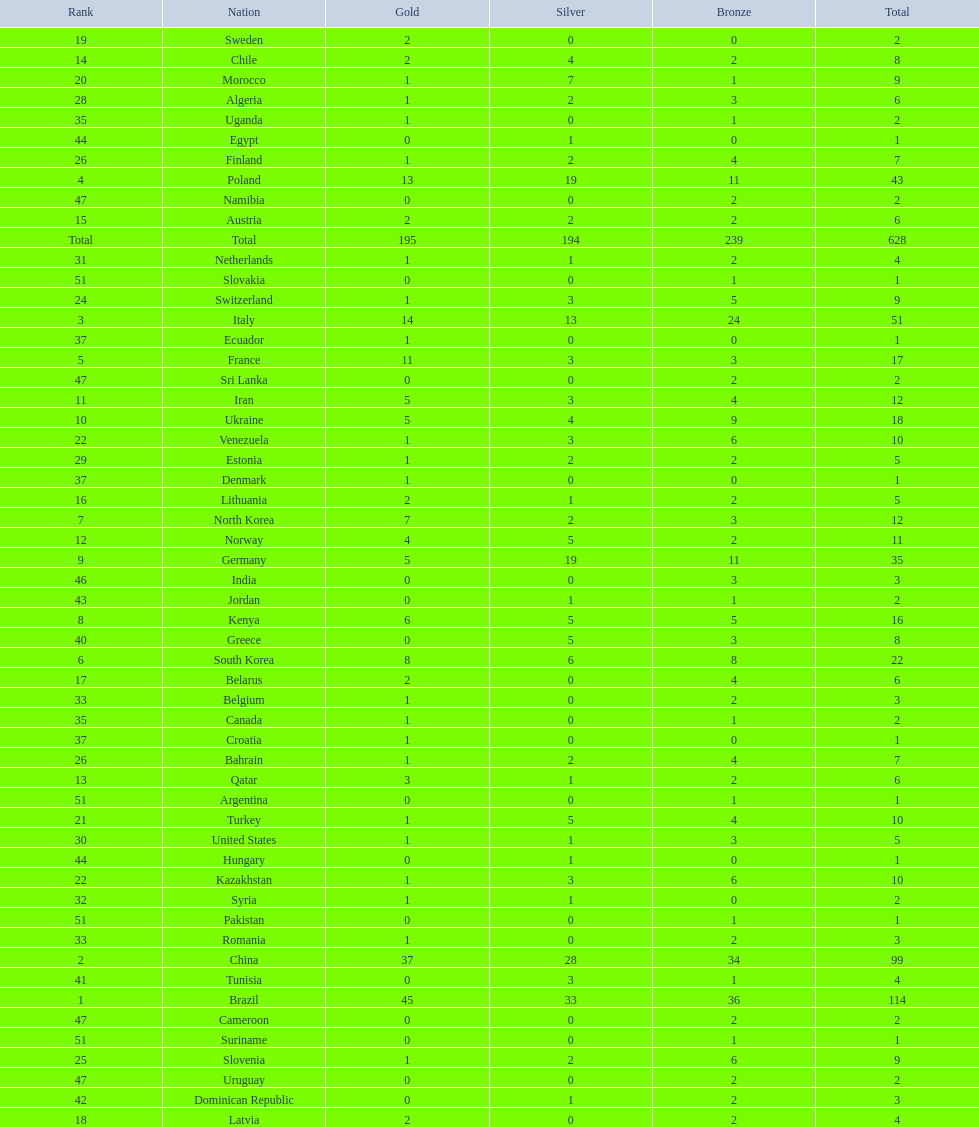Which type of medal does belarus not have? Silver. 